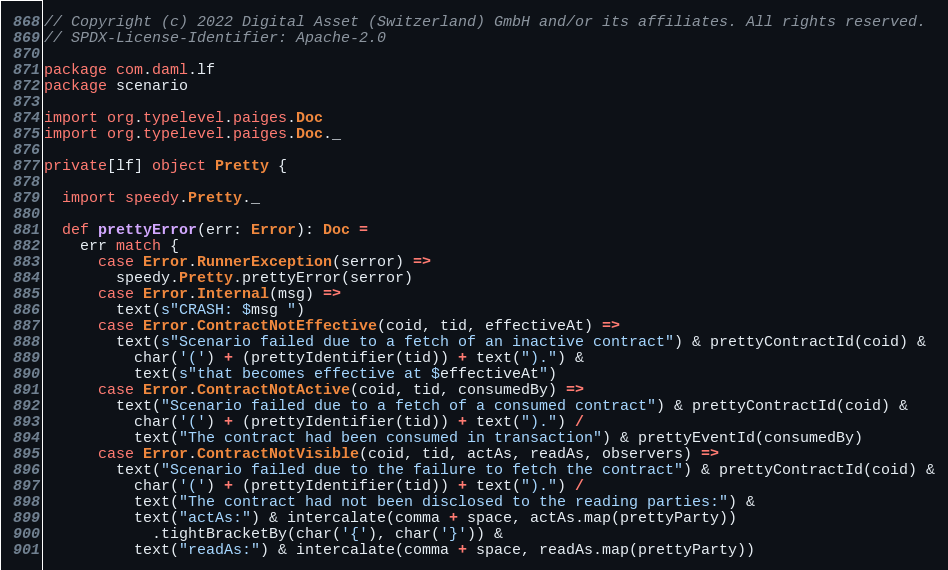Convert code to text. <code><loc_0><loc_0><loc_500><loc_500><_Scala_>// Copyright (c) 2022 Digital Asset (Switzerland) GmbH and/or its affiliates. All rights reserved.
// SPDX-License-Identifier: Apache-2.0

package com.daml.lf
package scenario

import org.typelevel.paiges.Doc
import org.typelevel.paiges.Doc._

private[lf] object Pretty {

  import speedy.Pretty._

  def prettyError(err: Error): Doc =
    err match {
      case Error.RunnerException(serror) =>
        speedy.Pretty.prettyError(serror)
      case Error.Internal(msg) =>
        text(s"CRASH: $msg ")
      case Error.ContractNotEffective(coid, tid, effectiveAt) =>
        text(s"Scenario failed due to a fetch of an inactive contract") & prettyContractId(coid) &
          char('(') + (prettyIdentifier(tid)) + text(").") &
          text(s"that becomes effective at $effectiveAt")
      case Error.ContractNotActive(coid, tid, consumedBy) =>
        text("Scenario failed due to a fetch of a consumed contract") & prettyContractId(coid) &
          char('(') + (prettyIdentifier(tid)) + text(").") /
          text("The contract had been consumed in transaction") & prettyEventId(consumedBy)
      case Error.ContractNotVisible(coid, tid, actAs, readAs, observers) =>
        text("Scenario failed due to the failure to fetch the contract") & prettyContractId(coid) &
          char('(') + (prettyIdentifier(tid)) + text(").") /
          text("The contract had not been disclosed to the reading parties:") &
          text("actAs:") & intercalate(comma + space, actAs.map(prettyParty))
            .tightBracketBy(char('{'), char('}')) &
          text("readAs:") & intercalate(comma + space, readAs.map(prettyParty))</code> 